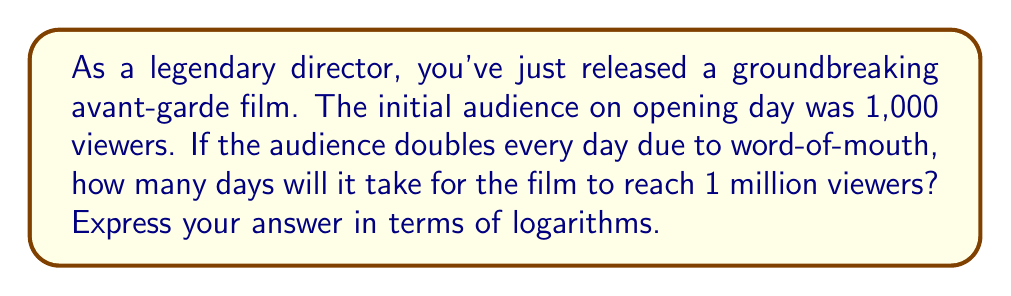Can you answer this question? Let's approach this step-by-step:

1) Let $x$ be the number of days it takes to reach 1 million viewers.

2) We can express the number of viewers after $x$ days as:
   $$1000 \cdot 2^x = 1,000,000$$

3) Dividing both sides by 1000:
   $$2^x = 1000$$

4) To solve for $x$, we need to take the logarithm of both sides. Let's use log base 2:
   $$\log_2(2^x) = \log_2(1000)$$

5) The left side simplifies due to the logarithm rule $\log_a(a^x) = x$:
   $$x = \log_2(1000)$$

6) We can express this in terms of natural logarithm (ln) using the change of base formula:
   $$x = \frac{\ln(1000)}{\ln(2)}$$

This expression gives us the exact number of days needed to reach 1 million viewers.
Answer: $\frac{\ln(1000)}{\ln(2)}$ days 